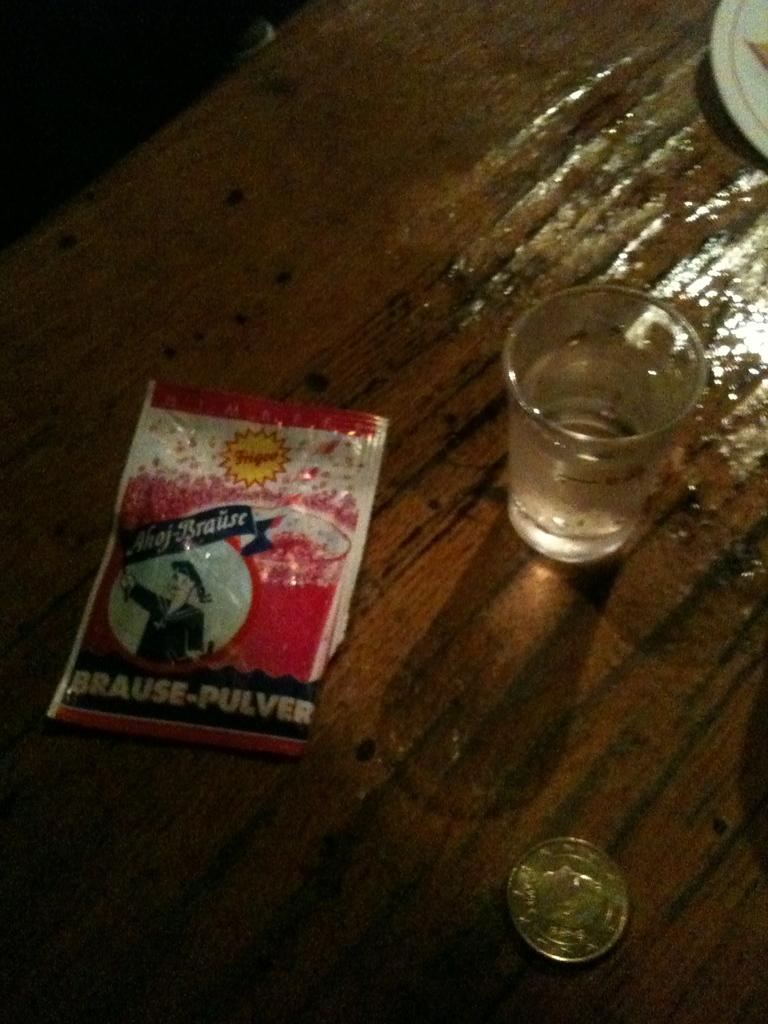<image>
Offer a succinct explanation of the picture presented. A package has the words Brause-Pulver on the bottom. 